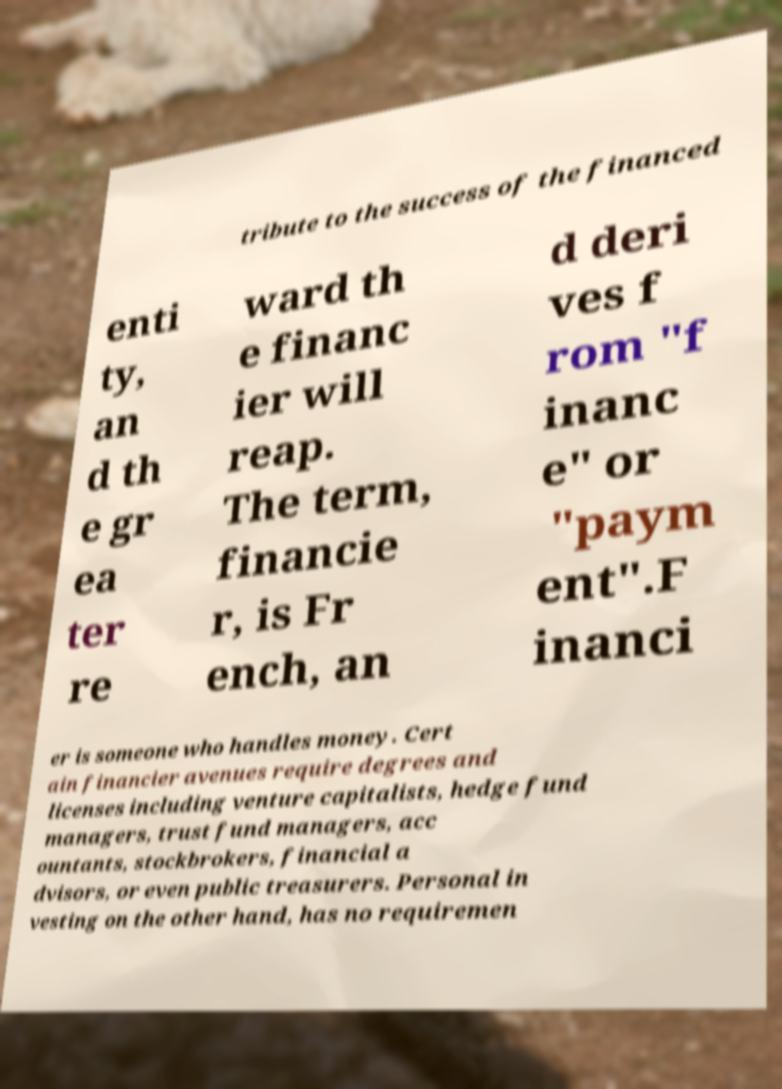Can you accurately transcribe the text from the provided image for me? tribute to the success of the financed enti ty, an d th e gr ea ter re ward th e financ ier will reap. The term, financie r, is Fr ench, an d deri ves f rom "f inanc e" or "paym ent".F inanci er is someone who handles money. Cert ain financier avenues require degrees and licenses including venture capitalists, hedge fund managers, trust fund managers, acc ountants, stockbrokers, financial a dvisors, or even public treasurers. Personal in vesting on the other hand, has no requiremen 